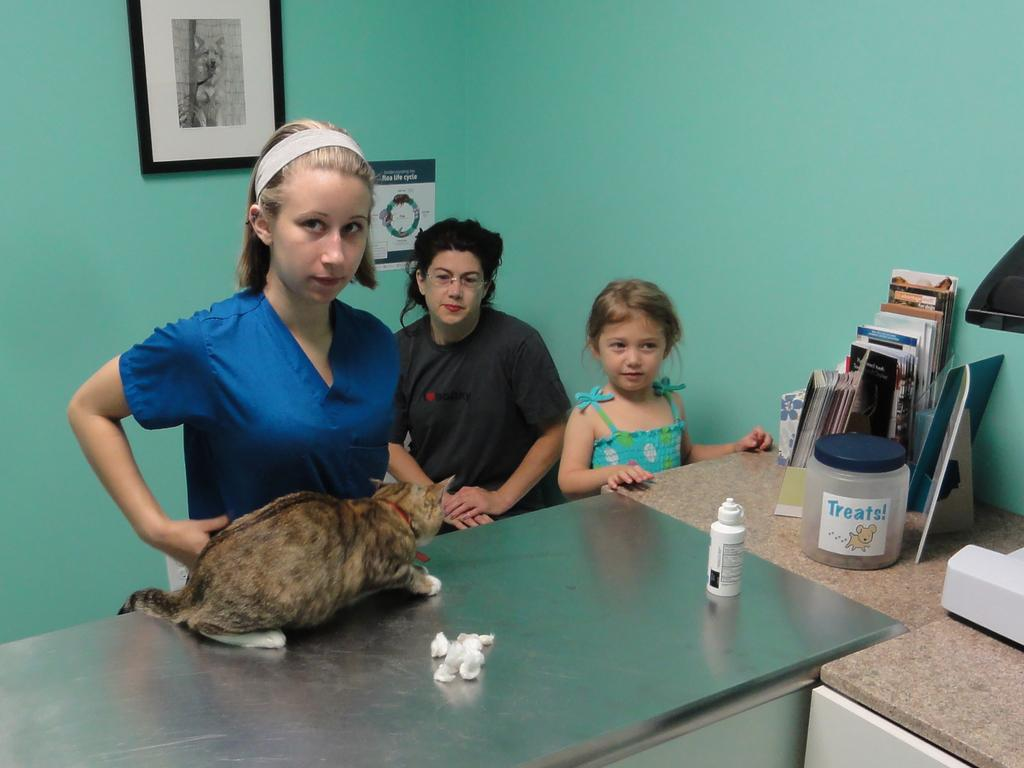What type of animal can be seen in the image? There is a cat in the image. What other objects can be seen in the image? There is a bottle, a container, books, and frames in the image. Where are the frames located in the image? The frames are on a table in the image. How many people are present in the image? There are 3 people in the image. What is the color of the wall where the frames are located? The frames are on a green wall. What type of toys can be seen in the image? There are no toys present in the image. How many cherries are on the table in the image? There are no cherries present in the image. 